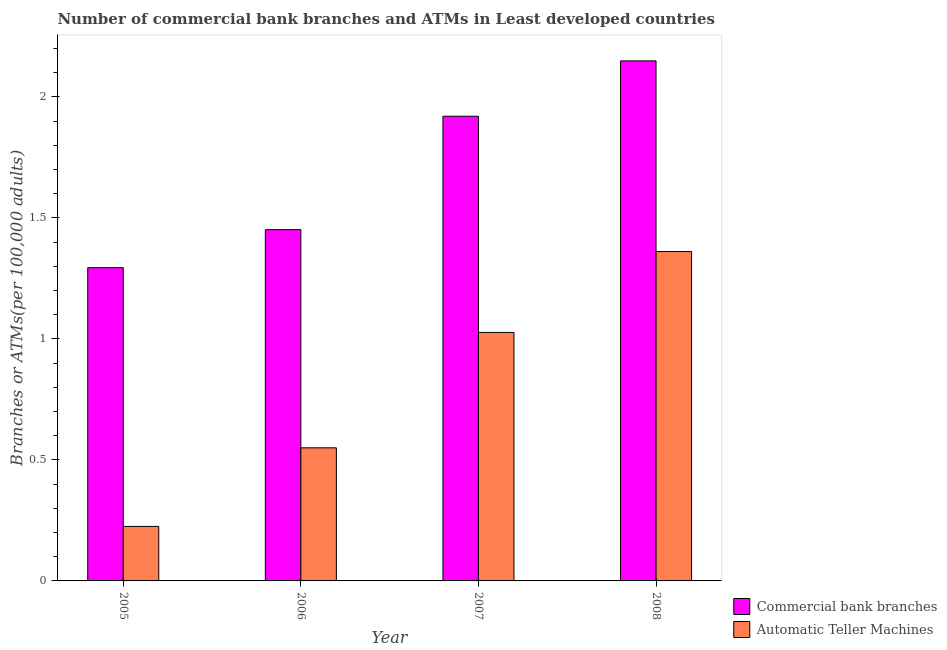How many groups of bars are there?
Keep it short and to the point. 4. Are the number of bars per tick equal to the number of legend labels?
Offer a terse response. Yes. How many bars are there on the 3rd tick from the right?
Provide a short and direct response. 2. In how many cases, is the number of bars for a given year not equal to the number of legend labels?
Give a very brief answer. 0. What is the number of atms in 2005?
Offer a very short reply. 0.23. Across all years, what is the maximum number of commercal bank branches?
Offer a very short reply. 2.15. Across all years, what is the minimum number of atms?
Give a very brief answer. 0.23. In which year was the number of commercal bank branches maximum?
Your answer should be compact. 2008. In which year was the number of commercal bank branches minimum?
Offer a very short reply. 2005. What is the total number of atms in the graph?
Give a very brief answer. 3.16. What is the difference between the number of commercal bank branches in 2006 and that in 2007?
Ensure brevity in your answer.  -0.47. What is the difference between the number of commercal bank branches in 2005 and the number of atms in 2007?
Offer a terse response. -0.63. What is the average number of commercal bank branches per year?
Ensure brevity in your answer.  1.7. In the year 2006, what is the difference between the number of commercal bank branches and number of atms?
Make the answer very short. 0. What is the ratio of the number of commercal bank branches in 2005 to that in 2006?
Provide a short and direct response. 0.89. Is the number of atms in 2006 less than that in 2008?
Your answer should be very brief. Yes. What is the difference between the highest and the second highest number of atms?
Ensure brevity in your answer.  0.33. What is the difference between the highest and the lowest number of commercal bank branches?
Provide a succinct answer. 0.85. In how many years, is the number of commercal bank branches greater than the average number of commercal bank branches taken over all years?
Your response must be concise. 2. What does the 1st bar from the left in 2006 represents?
Provide a succinct answer. Commercial bank branches. What does the 2nd bar from the right in 2007 represents?
Your response must be concise. Commercial bank branches. How many bars are there?
Give a very brief answer. 8. Are all the bars in the graph horizontal?
Keep it short and to the point. No. How many years are there in the graph?
Make the answer very short. 4. Are the values on the major ticks of Y-axis written in scientific E-notation?
Your answer should be compact. No. Does the graph contain any zero values?
Your answer should be compact. No. Where does the legend appear in the graph?
Your answer should be very brief. Bottom right. How many legend labels are there?
Your answer should be very brief. 2. What is the title of the graph?
Provide a succinct answer. Number of commercial bank branches and ATMs in Least developed countries. What is the label or title of the X-axis?
Your answer should be compact. Year. What is the label or title of the Y-axis?
Offer a very short reply. Branches or ATMs(per 100,0 adults). What is the Branches or ATMs(per 100,000 adults) in Commercial bank branches in 2005?
Your response must be concise. 1.29. What is the Branches or ATMs(per 100,000 adults) of Automatic Teller Machines in 2005?
Give a very brief answer. 0.23. What is the Branches or ATMs(per 100,000 adults) in Commercial bank branches in 2006?
Offer a very short reply. 1.45. What is the Branches or ATMs(per 100,000 adults) in Automatic Teller Machines in 2006?
Offer a terse response. 0.55. What is the Branches or ATMs(per 100,000 adults) of Commercial bank branches in 2007?
Provide a short and direct response. 1.92. What is the Branches or ATMs(per 100,000 adults) in Automatic Teller Machines in 2007?
Offer a terse response. 1.03. What is the Branches or ATMs(per 100,000 adults) in Commercial bank branches in 2008?
Make the answer very short. 2.15. What is the Branches or ATMs(per 100,000 adults) of Automatic Teller Machines in 2008?
Make the answer very short. 1.36. Across all years, what is the maximum Branches or ATMs(per 100,000 adults) of Commercial bank branches?
Give a very brief answer. 2.15. Across all years, what is the maximum Branches or ATMs(per 100,000 adults) in Automatic Teller Machines?
Offer a very short reply. 1.36. Across all years, what is the minimum Branches or ATMs(per 100,000 adults) of Commercial bank branches?
Your response must be concise. 1.29. Across all years, what is the minimum Branches or ATMs(per 100,000 adults) of Automatic Teller Machines?
Your answer should be very brief. 0.23. What is the total Branches or ATMs(per 100,000 adults) in Commercial bank branches in the graph?
Provide a succinct answer. 6.82. What is the total Branches or ATMs(per 100,000 adults) in Automatic Teller Machines in the graph?
Ensure brevity in your answer.  3.16. What is the difference between the Branches or ATMs(per 100,000 adults) of Commercial bank branches in 2005 and that in 2006?
Your answer should be very brief. -0.16. What is the difference between the Branches or ATMs(per 100,000 adults) in Automatic Teller Machines in 2005 and that in 2006?
Make the answer very short. -0.32. What is the difference between the Branches or ATMs(per 100,000 adults) in Commercial bank branches in 2005 and that in 2007?
Keep it short and to the point. -0.63. What is the difference between the Branches or ATMs(per 100,000 adults) in Automatic Teller Machines in 2005 and that in 2007?
Make the answer very short. -0.8. What is the difference between the Branches or ATMs(per 100,000 adults) in Commercial bank branches in 2005 and that in 2008?
Give a very brief answer. -0.85. What is the difference between the Branches or ATMs(per 100,000 adults) of Automatic Teller Machines in 2005 and that in 2008?
Ensure brevity in your answer.  -1.14. What is the difference between the Branches or ATMs(per 100,000 adults) of Commercial bank branches in 2006 and that in 2007?
Your answer should be very brief. -0.47. What is the difference between the Branches or ATMs(per 100,000 adults) of Automatic Teller Machines in 2006 and that in 2007?
Keep it short and to the point. -0.48. What is the difference between the Branches or ATMs(per 100,000 adults) in Commercial bank branches in 2006 and that in 2008?
Provide a succinct answer. -0.7. What is the difference between the Branches or ATMs(per 100,000 adults) of Automatic Teller Machines in 2006 and that in 2008?
Your response must be concise. -0.81. What is the difference between the Branches or ATMs(per 100,000 adults) of Commercial bank branches in 2007 and that in 2008?
Provide a short and direct response. -0.23. What is the difference between the Branches or ATMs(per 100,000 adults) of Automatic Teller Machines in 2007 and that in 2008?
Provide a succinct answer. -0.33. What is the difference between the Branches or ATMs(per 100,000 adults) in Commercial bank branches in 2005 and the Branches or ATMs(per 100,000 adults) in Automatic Teller Machines in 2006?
Your response must be concise. 0.74. What is the difference between the Branches or ATMs(per 100,000 adults) of Commercial bank branches in 2005 and the Branches or ATMs(per 100,000 adults) of Automatic Teller Machines in 2007?
Keep it short and to the point. 0.27. What is the difference between the Branches or ATMs(per 100,000 adults) in Commercial bank branches in 2005 and the Branches or ATMs(per 100,000 adults) in Automatic Teller Machines in 2008?
Your answer should be compact. -0.07. What is the difference between the Branches or ATMs(per 100,000 adults) of Commercial bank branches in 2006 and the Branches or ATMs(per 100,000 adults) of Automatic Teller Machines in 2007?
Offer a very short reply. 0.42. What is the difference between the Branches or ATMs(per 100,000 adults) of Commercial bank branches in 2006 and the Branches or ATMs(per 100,000 adults) of Automatic Teller Machines in 2008?
Your answer should be very brief. 0.09. What is the difference between the Branches or ATMs(per 100,000 adults) of Commercial bank branches in 2007 and the Branches or ATMs(per 100,000 adults) of Automatic Teller Machines in 2008?
Ensure brevity in your answer.  0.56. What is the average Branches or ATMs(per 100,000 adults) of Commercial bank branches per year?
Offer a very short reply. 1.7. What is the average Branches or ATMs(per 100,000 adults) of Automatic Teller Machines per year?
Ensure brevity in your answer.  0.79. In the year 2005, what is the difference between the Branches or ATMs(per 100,000 adults) in Commercial bank branches and Branches or ATMs(per 100,000 adults) in Automatic Teller Machines?
Your response must be concise. 1.07. In the year 2006, what is the difference between the Branches or ATMs(per 100,000 adults) of Commercial bank branches and Branches or ATMs(per 100,000 adults) of Automatic Teller Machines?
Your response must be concise. 0.9. In the year 2007, what is the difference between the Branches or ATMs(per 100,000 adults) of Commercial bank branches and Branches or ATMs(per 100,000 adults) of Automatic Teller Machines?
Your response must be concise. 0.89. In the year 2008, what is the difference between the Branches or ATMs(per 100,000 adults) of Commercial bank branches and Branches or ATMs(per 100,000 adults) of Automatic Teller Machines?
Provide a succinct answer. 0.79. What is the ratio of the Branches or ATMs(per 100,000 adults) in Commercial bank branches in 2005 to that in 2006?
Make the answer very short. 0.89. What is the ratio of the Branches or ATMs(per 100,000 adults) of Automatic Teller Machines in 2005 to that in 2006?
Your response must be concise. 0.41. What is the ratio of the Branches or ATMs(per 100,000 adults) in Commercial bank branches in 2005 to that in 2007?
Give a very brief answer. 0.67. What is the ratio of the Branches or ATMs(per 100,000 adults) in Automatic Teller Machines in 2005 to that in 2007?
Offer a very short reply. 0.22. What is the ratio of the Branches or ATMs(per 100,000 adults) in Commercial bank branches in 2005 to that in 2008?
Offer a terse response. 0.6. What is the ratio of the Branches or ATMs(per 100,000 adults) in Automatic Teller Machines in 2005 to that in 2008?
Provide a succinct answer. 0.17. What is the ratio of the Branches or ATMs(per 100,000 adults) in Commercial bank branches in 2006 to that in 2007?
Your answer should be very brief. 0.76. What is the ratio of the Branches or ATMs(per 100,000 adults) of Automatic Teller Machines in 2006 to that in 2007?
Make the answer very short. 0.54. What is the ratio of the Branches or ATMs(per 100,000 adults) of Commercial bank branches in 2006 to that in 2008?
Provide a short and direct response. 0.68. What is the ratio of the Branches or ATMs(per 100,000 adults) in Automatic Teller Machines in 2006 to that in 2008?
Make the answer very short. 0.4. What is the ratio of the Branches or ATMs(per 100,000 adults) of Commercial bank branches in 2007 to that in 2008?
Your answer should be compact. 0.89. What is the ratio of the Branches or ATMs(per 100,000 adults) in Automatic Teller Machines in 2007 to that in 2008?
Your answer should be very brief. 0.75. What is the difference between the highest and the second highest Branches or ATMs(per 100,000 adults) of Commercial bank branches?
Your answer should be very brief. 0.23. What is the difference between the highest and the second highest Branches or ATMs(per 100,000 adults) in Automatic Teller Machines?
Your answer should be very brief. 0.33. What is the difference between the highest and the lowest Branches or ATMs(per 100,000 adults) in Commercial bank branches?
Offer a very short reply. 0.85. What is the difference between the highest and the lowest Branches or ATMs(per 100,000 adults) in Automatic Teller Machines?
Your answer should be compact. 1.14. 